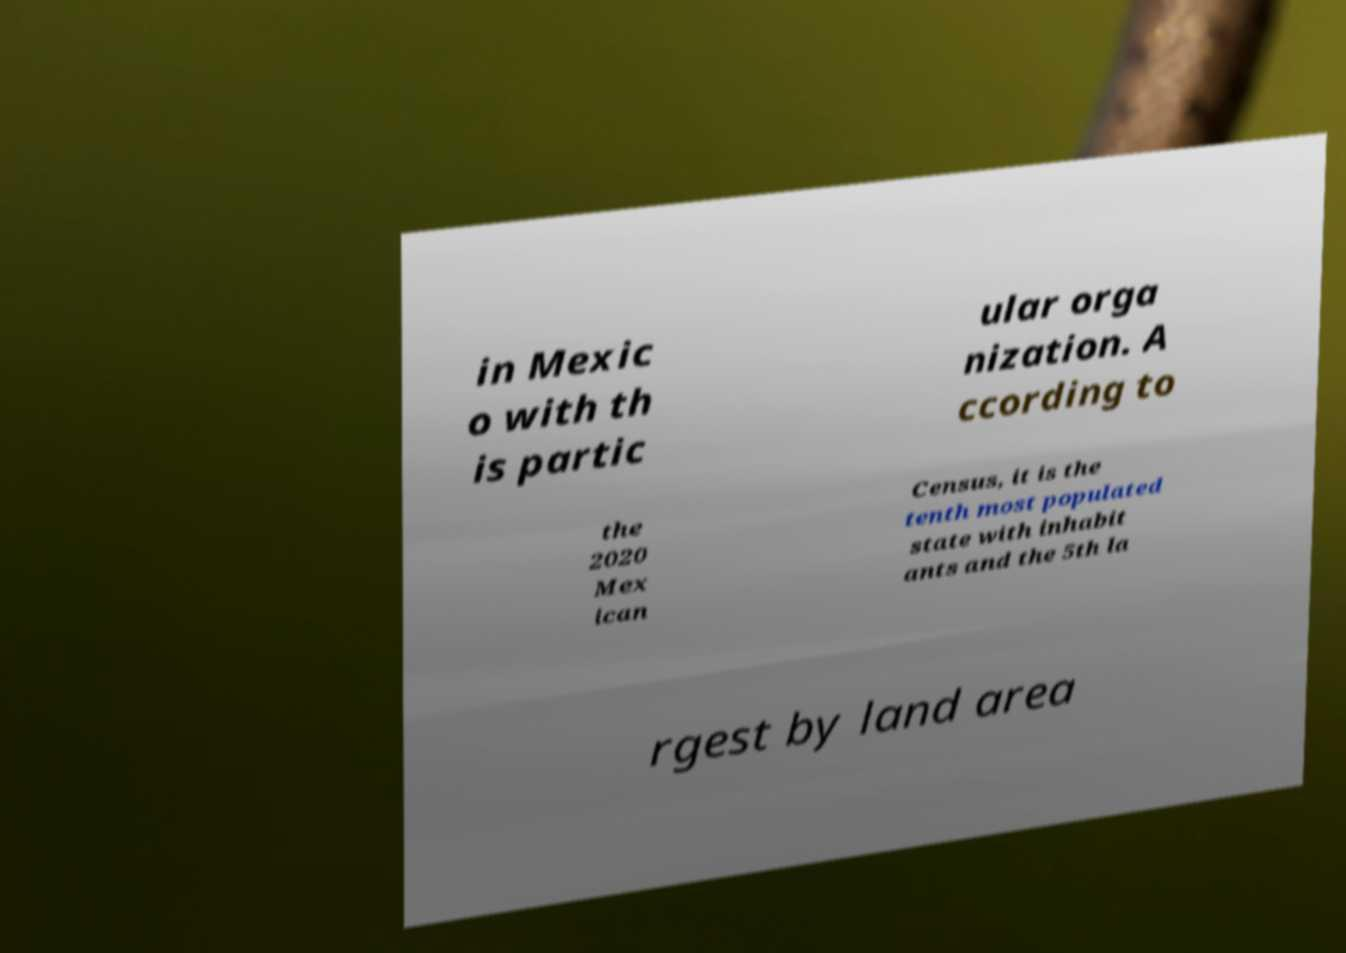Can you read and provide the text displayed in the image?This photo seems to have some interesting text. Can you extract and type it out for me? in Mexic o with th is partic ular orga nization. A ccording to the 2020 Mex ican Census, it is the tenth most populated state with inhabit ants and the 5th la rgest by land area 